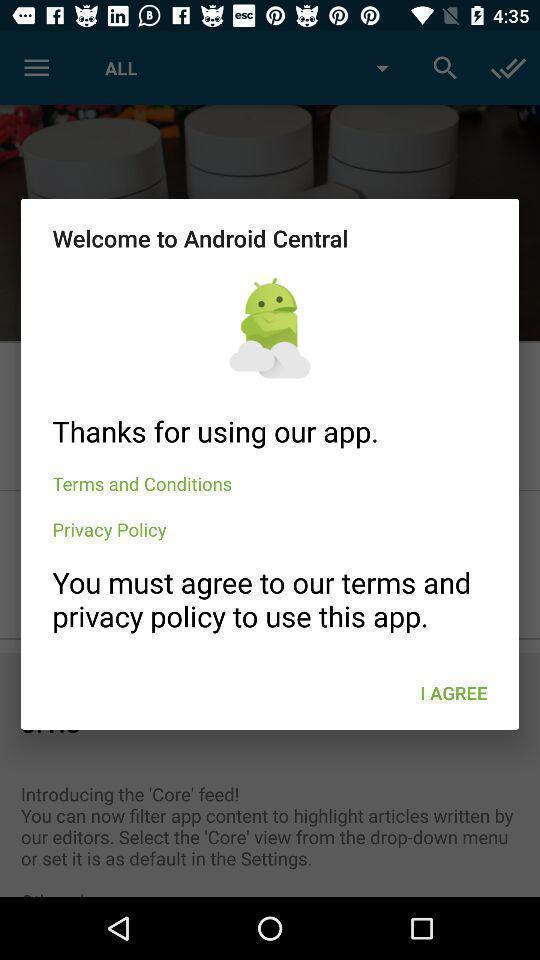Tell me about the visual elements in this screen capture. Welcome page of social app. 